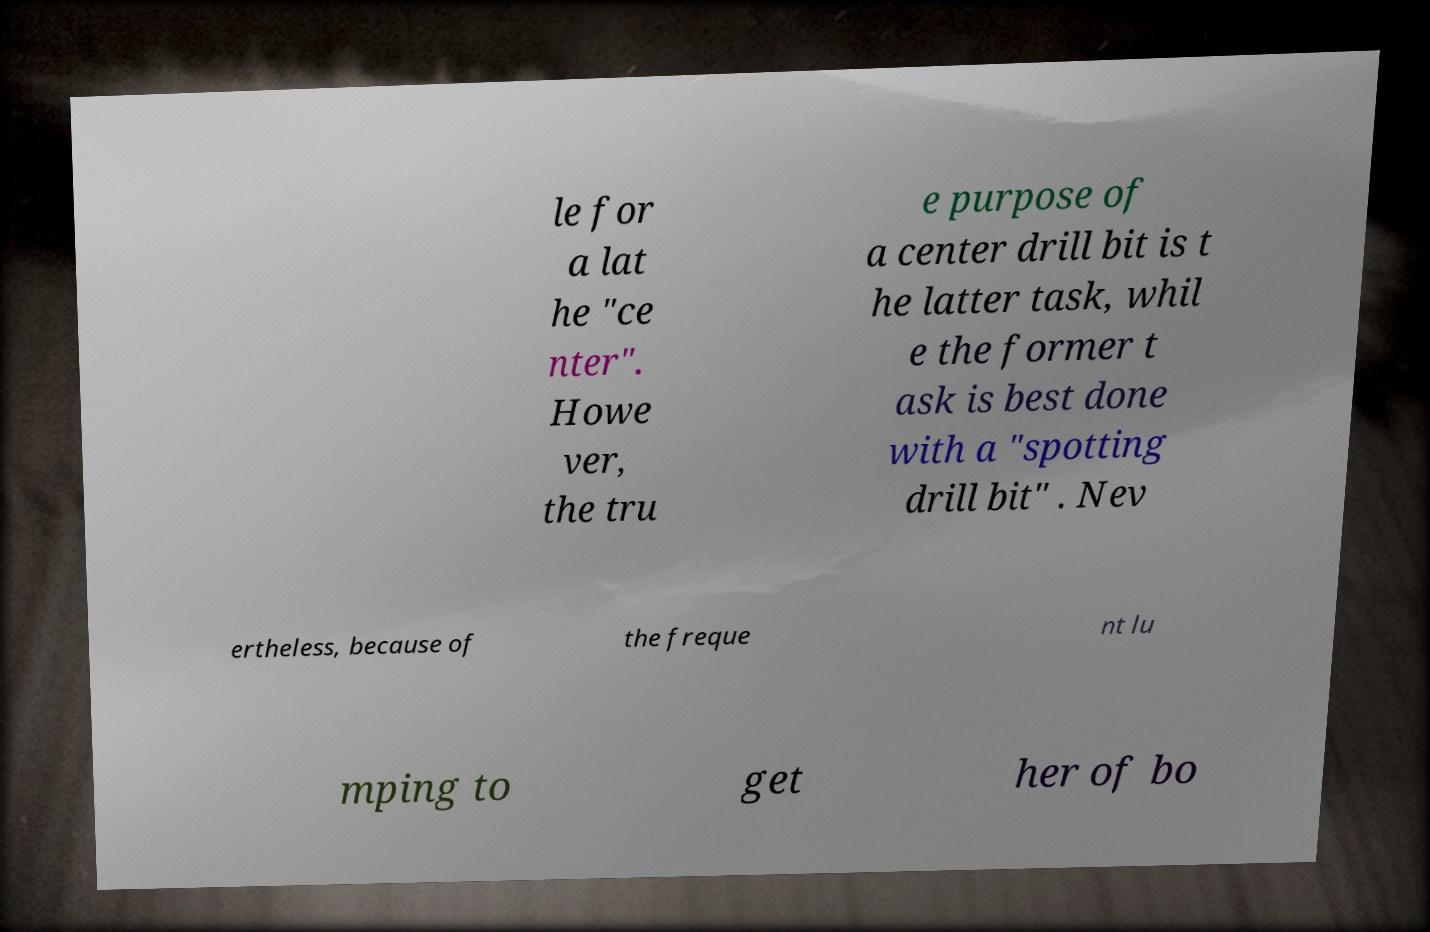Could you assist in decoding the text presented in this image and type it out clearly? le for a lat he "ce nter". Howe ver, the tru e purpose of a center drill bit is t he latter task, whil e the former t ask is best done with a "spotting drill bit" . Nev ertheless, because of the freque nt lu mping to get her of bo 